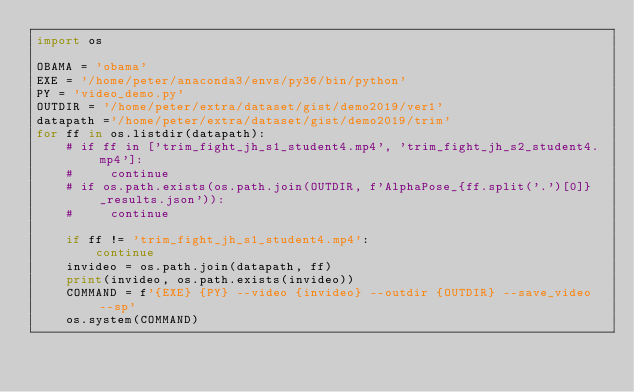<code> <loc_0><loc_0><loc_500><loc_500><_Python_>import os

OBAMA = 'obama'
EXE = '/home/peter/anaconda3/envs/py36/bin/python'  
PY = 'video_demo.py'
OUTDIR = '/home/peter/extra/dataset/gist/demo2019/ver1'
datapath ='/home/peter/extra/dataset/gist/demo2019/trim'
for ff in os.listdir(datapath):
    # if ff in ['trim_fight_jh_s1_student4.mp4', 'trim_fight_jh_s2_student4.mp4']:
    #     continue
    # if os.path.exists(os.path.join(OUTDIR, f'AlphaPose_{ff.split('.')[0]}_results.json')):
    #     continue

    if ff != 'trim_fight_jh_s1_student4.mp4':
        continue
    invideo = os.path.join(datapath, ff)
    print(invideo, os.path.exists(invideo))
    COMMAND = f'{EXE} {PY} --video {invideo} --outdir {OUTDIR} --save_video --sp'
    os.system(COMMAND)

</code> 